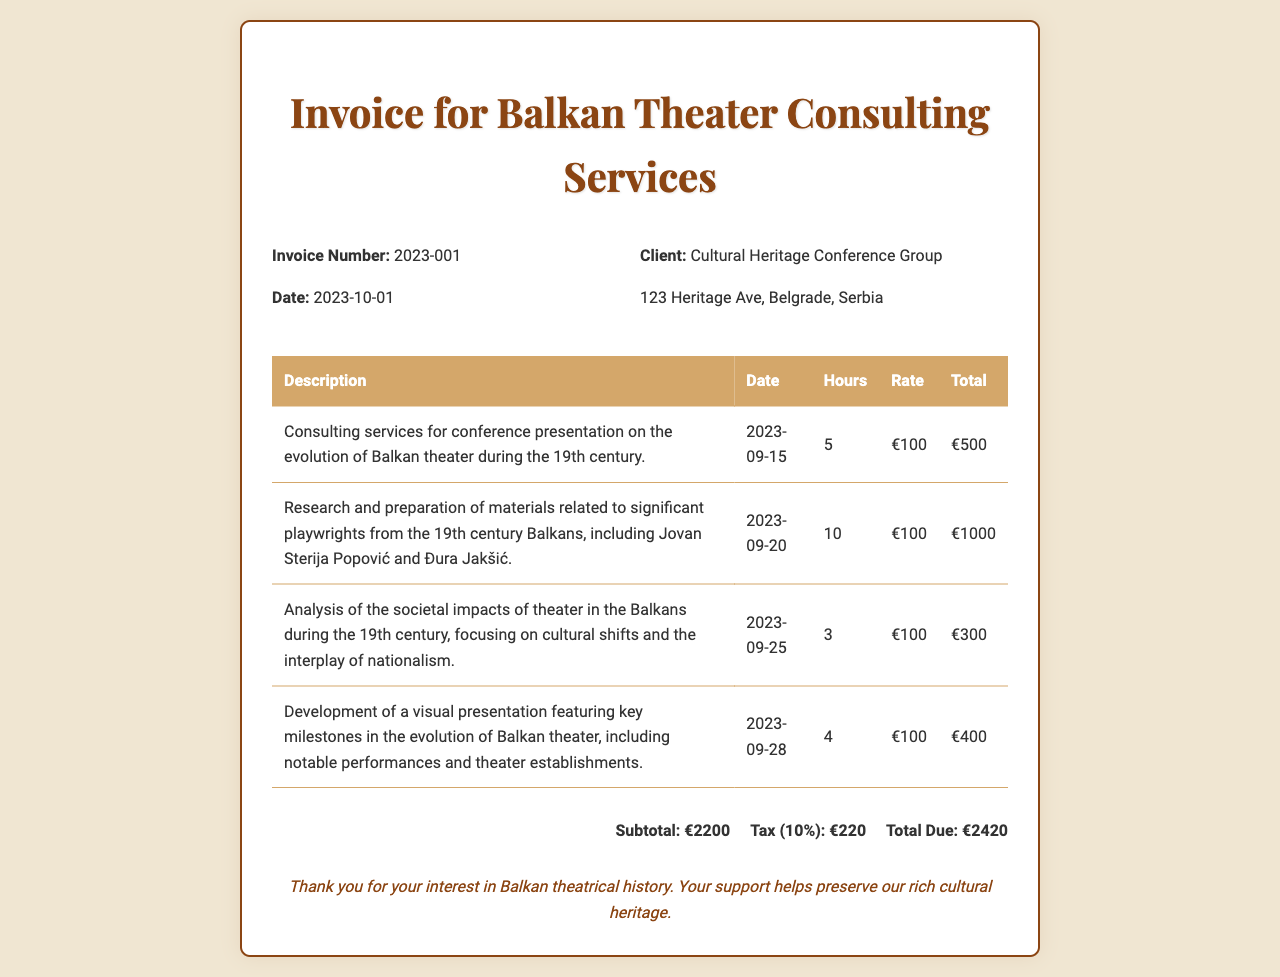What is the invoice number? The invoice number is listed in the document as a specific identifier for the transaction.
Answer: 2023-001 What is the date of the invoice? The date of the invoice indicates when the services were billed and is shown prominently in the document.
Answer: 2023-10-01 Who is the client for these consulting services? The client’s name and address are explicitly mentioned in the document, indicating the entity receiving the invoice.
Answer: Cultural Heritage Conference Group How many hours were billed for the first consulting service? The hours billed for each service are detailed in the table, allowing for quick retrieval of this specific information.
Answer: 5 What is the subtotal amount before tax? The subtotal represents the total charge for services rendered before any tax is applied, as stated in the invoice.
Answer: €2200 What percentage is the tax applied to the subtotal? The document specifies the tax rate applied to the subtotal, which is important for calculating the total due.
Answer: 10% What is the total amount due? The total amount due is the final amount calculated after adding tax to the subtotal, clearly summarized at the end of the invoice.
Answer: €2420 What type of services were billed on 2023-09-20? Each line item describes a type of service, which helps in understanding the content of the billed services.
Answer: Research and preparation of materials What significant playwright was mentioned in the document? The document refers to notable figures related to the consulting services, highlighting the historical connections.
Answer: Jovan Sterija Popović 